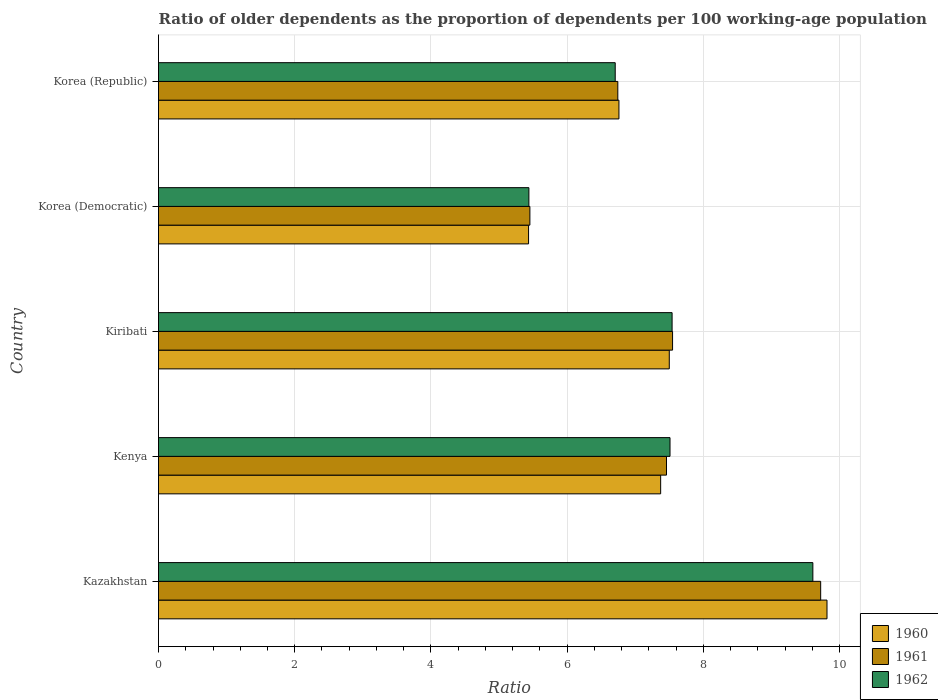How many different coloured bars are there?
Provide a succinct answer. 3. Are the number of bars on each tick of the Y-axis equal?
Offer a terse response. Yes. What is the label of the 3rd group of bars from the top?
Your response must be concise. Kiribati. What is the age dependency ratio(old) in 1962 in Kiribati?
Your response must be concise. 7.54. Across all countries, what is the maximum age dependency ratio(old) in 1960?
Your answer should be compact. 9.81. Across all countries, what is the minimum age dependency ratio(old) in 1962?
Offer a very short reply. 5.44. In which country was the age dependency ratio(old) in 1962 maximum?
Offer a very short reply. Kazakhstan. In which country was the age dependency ratio(old) in 1962 minimum?
Make the answer very short. Korea (Democratic). What is the total age dependency ratio(old) in 1962 in the graph?
Provide a succinct answer. 36.8. What is the difference between the age dependency ratio(old) in 1962 in Kazakhstan and that in Kiribati?
Provide a short and direct response. 2.07. What is the difference between the age dependency ratio(old) in 1960 in Kiribati and the age dependency ratio(old) in 1961 in Kenya?
Ensure brevity in your answer.  0.04. What is the average age dependency ratio(old) in 1961 per country?
Provide a short and direct response. 7.38. What is the difference between the age dependency ratio(old) in 1960 and age dependency ratio(old) in 1962 in Korea (Republic)?
Make the answer very short. 0.05. In how many countries, is the age dependency ratio(old) in 1961 greater than 0.4 ?
Your answer should be compact. 5. What is the ratio of the age dependency ratio(old) in 1962 in Kazakhstan to that in Kiribati?
Make the answer very short. 1.27. What is the difference between the highest and the second highest age dependency ratio(old) in 1962?
Offer a very short reply. 2.07. What is the difference between the highest and the lowest age dependency ratio(old) in 1961?
Your response must be concise. 4.27. Is the sum of the age dependency ratio(old) in 1961 in Kenya and Korea (Democratic) greater than the maximum age dependency ratio(old) in 1962 across all countries?
Give a very brief answer. Yes. What does the 1st bar from the bottom in Kenya represents?
Make the answer very short. 1960. Is it the case that in every country, the sum of the age dependency ratio(old) in 1961 and age dependency ratio(old) in 1962 is greater than the age dependency ratio(old) in 1960?
Your response must be concise. Yes. How many bars are there?
Provide a short and direct response. 15. Are all the bars in the graph horizontal?
Offer a terse response. Yes. How many countries are there in the graph?
Provide a succinct answer. 5. What is the difference between two consecutive major ticks on the X-axis?
Ensure brevity in your answer.  2. Are the values on the major ticks of X-axis written in scientific E-notation?
Offer a very short reply. No. Does the graph contain any zero values?
Provide a succinct answer. No. Where does the legend appear in the graph?
Provide a succinct answer. Bottom right. What is the title of the graph?
Provide a succinct answer. Ratio of older dependents as the proportion of dependents per 100 working-age population. Does "2015" appear as one of the legend labels in the graph?
Provide a succinct answer. No. What is the label or title of the X-axis?
Your response must be concise. Ratio. What is the Ratio in 1960 in Kazakhstan?
Make the answer very short. 9.81. What is the Ratio in 1961 in Kazakhstan?
Ensure brevity in your answer.  9.72. What is the Ratio of 1962 in Kazakhstan?
Your answer should be compact. 9.61. What is the Ratio of 1960 in Kenya?
Your response must be concise. 7.37. What is the Ratio in 1961 in Kenya?
Offer a terse response. 7.46. What is the Ratio in 1962 in Kenya?
Provide a succinct answer. 7.51. What is the Ratio in 1960 in Kiribati?
Ensure brevity in your answer.  7.5. What is the Ratio in 1961 in Kiribati?
Your answer should be compact. 7.55. What is the Ratio of 1962 in Kiribati?
Your answer should be compact. 7.54. What is the Ratio in 1960 in Korea (Democratic)?
Offer a terse response. 5.43. What is the Ratio of 1961 in Korea (Democratic)?
Provide a succinct answer. 5.45. What is the Ratio of 1962 in Korea (Democratic)?
Provide a short and direct response. 5.44. What is the Ratio of 1960 in Korea (Republic)?
Keep it short and to the point. 6.76. What is the Ratio in 1961 in Korea (Republic)?
Make the answer very short. 6.74. What is the Ratio in 1962 in Korea (Republic)?
Your response must be concise. 6.7. Across all countries, what is the maximum Ratio of 1960?
Provide a short and direct response. 9.81. Across all countries, what is the maximum Ratio of 1961?
Your answer should be compact. 9.72. Across all countries, what is the maximum Ratio in 1962?
Offer a very short reply. 9.61. Across all countries, what is the minimum Ratio in 1960?
Your answer should be very brief. 5.43. Across all countries, what is the minimum Ratio of 1961?
Your response must be concise. 5.45. Across all countries, what is the minimum Ratio of 1962?
Your answer should be compact. 5.44. What is the total Ratio in 1960 in the graph?
Ensure brevity in your answer.  36.88. What is the total Ratio in 1961 in the graph?
Your answer should be very brief. 36.92. What is the total Ratio in 1962 in the graph?
Offer a terse response. 36.8. What is the difference between the Ratio of 1960 in Kazakhstan and that in Kenya?
Your answer should be compact. 2.44. What is the difference between the Ratio of 1961 in Kazakhstan and that in Kenya?
Ensure brevity in your answer.  2.26. What is the difference between the Ratio of 1962 in Kazakhstan and that in Kenya?
Make the answer very short. 2.1. What is the difference between the Ratio of 1960 in Kazakhstan and that in Kiribati?
Ensure brevity in your answer.  2.32. What is the difference between the Ratio in 1961 in Kazakhstan and that in Kiribati?
Give a very brief answer. 2.17. What is the difference between the Ratio in 1962 in Kazakhstan and that in Kiribati?
Offer a very short reply. 2.07. What is the difference between the Ratio in 1960 in Kazakhstan and that in Korea (Democratic)?
Your response must be concise. 4.38. What is the difference between the Ratio of 1961 in Kazakhstan and that in Korea (Democratic)?
Your response must be concise. 4.27. What is the difference between the Ratio in 1962 in Kazakhstan and that in Korea (Democratic)?
Provide a succinct answer. 4.17. What is the difference between the Ratio of 1960 in Kazakhstan and that in Korea (Republic)?
Offer a very short reply. 3.05. What is the difference between the Ratio of 1961 in Kazakhstan and that in Korea (Republic)?
Your answer should be compact. 2.98. What is the difference between the Ratio in 1962 in Kazakhstan and that in Korea (Republic)?
Offer a very short reply. 2.9. What is the difference between the Ratio of 1960 in Kenya and that in Kiribati?
Give a very brief answer. -0.13. What is the difference between the Ratio in 1961 in Kenya and that in Kiribati?
Give a very brief answer. -0.09. What is the difference between the Ratio in 1962 in Kenya and that in Kiribati?
Your response must be concise. -0.03. What is the difference between the Ratio of 1960 in Kenya and that in Korea (Democratic)?
Keep it short and to the point. 1.94. What is the difference between the Ratio of 1961 in Kenya and that in Korea (Democratic)?
Ensure brevity in your answer.  2.01. What is the difference between the Ratio of 1962 in Kenya and that in Korea (Democratic)?
Your answer should be very brief. 2.07. What is the difference between the Ratio of 1960 in Kenya and that in Korea (Republic)?
Your response must be concise. 0.61. What is the difference between the Ratio in 1961 in Kenya and that in Korea (Republic)?
Give a very brief answer. 0.71. What is the difference between the Ratio of 1962 in Kenya and that in Korea (Republic)?
Make the answer very short. 0.8. What is the difference between the Ratio in 1960 in Kiribati and that in Korea (Democratic)?
Ensure brevity in your answer.  2.07. What is the difference between the Ratio of 1961 in Kiribati and that in Korea (Democratic)?
Offer a terse response. 2.09. What is the difference between the Ratio of 1962 in Kiribati and that in Korea (Democratic)?
Offer a very short reply. 2.1. What is the difference between the Ratio in 1960 in Kiribati and that in Korea (Republic)?
Your response must be concise. 0.74. What is the difference between the Ratio of 1961 in Kiribati and that in Korea (Republic)?
Provide a short and direct response. 0.8. What is the difference between the Ratio of 1962 in Kiribati and that in Korea (Republic)?
Your answer should be compact. 0.84. What is the difference between the Ratio of 1960 in Korea (Democratic) and that in Korea (Republic)?
Make the answer very short. -1.33. What is the difference between the Ratio of 1961 in Korea (Democratic) and that in Korea (Republic)?
Your answer should be very brief. -1.29. What is the difference between the Ratio in 1962 in Korea (Democratic) and that in Korea (Republic)?
Your answer should be compact. -1.27. What is the difference between the Ratio of 1960 in Kazakhstan and the Ratio of 1961 in Kenya?
Give a very brief answer. 2.36. What is the difference between the Ratio in 1960 in Kazakhstan and the Ratio in 1962 in Kenya?
Provide a short and direct response. 2.3. What is the difference between the Ratio of 1961 in Kazakhstan and the Ratio of 1962 in Kenya?
Your answer should be very brief. 2.21. What is the difference between the Ratio of 1960 in Kazakhstan and the Ratio of 1961 in Kiribati?
Provide a short and direct response. 2.27. What is the difference between the Ratio of 1960 in Kazakhstan and the Ratio of 1962 in Kiribati?
Your answer should be compact. 2.27. What is the difference between the Ratio in 1961 in Kazakhstan and the Ratio in 1962 in Kiribati?
Offer a very short reply. 2.18. What is the difference between the Ratio in 1960 in Kazakhstan and the Ratio in 1961 in Korea (Democratic)?
Offer a terse response. 4.36. What is the difference between the Ratio in 1960 in Kazakhstan and the Ratio in 1962 in Korea (Democratic)?
Your response must be concise. 4.38. What is the difference between the Ratio in 1961 in Kazakhstan and the Ratio in 1962 in Korea (Democratic)?
Your answer should be compact. 4.28. What is the difference between the Ratio of 1960 in Kazakhstan and the Ratio of 1961 in Korea (Republic)?
Give a very brief answer. 3.07. What is the difference between the Ratio of 1960 in Kazakhstan and the Ratio of 1962 in Korea (Republic)?
Provide a succinct answer. 3.11. What is the difference between the Ratio of 1961 in Kazakhstan and the Ratio of 1962 in Korea (Republic)?
Keep it short and to the point. 3.02. What is the difference between the Ratio in 1960 in Kenya and the Ratio in 1961 in Kiribati?
Offer a terse response. -0.17. What is the difference between the Ratio in 1960 in Kenya and the Ratio in 1962 in Kiribati?
Your answer should be compact. -0.17. What is the difference between the Ratio in 1961 in Kenya and the Ratio in 1962 in Kiribati?
Provide a short and direct response. -0.08. What is the difference between the Ratio of 1960 in Kenya and the Ratio of 1961 in Korea (Democratic)?
Your response must be concise. 1.92. What is the difference between the Ratio in 1960 in Kenya and the Ratio in 1962 in Korea (Democratic)?
Make the answer very short. 1.93. What is the difference between the Ratio of 1961 in Kenya and the Ratio of 1962 in Korea (Democratic)?
Provide a succinct answer. 2.02. What is the difference between the Ratio of 1960 in Kenya and the Ratio of 1961 in Korea (Republic)?
Provide a short and direct response. 0.63. What is the difference between the Ratio in 1960 in Kenya and the Ratio in 1962 in Korea (Republic)?
Provide a succinct answer. 0.67. What is the difference between the Ratio in 1961 in Kenya and the Ratio in 1962 in Korea (Republic)?
Keep it short and to the point. 0.75. What is the difference between the Ratio in 1960 in Kiribati and the Ratio in 1961 in Korea (Democratic)?
Provide a succinct answer. 2.05. What is the difference between the Ratio in 1960 in Kiribati and the Ratio in 1962 in Korea (Democratic)?
Ensure brevity in your answer.  2.06. What is the difference between the Ratio in 1961 in Kiribati and the Ratio in 1962 in Korea (Democratic)?
Provide a short and direct response. 2.11. What is the difference between the Ratio of 1960 in Kiribati and the Ratio of 1961 in Korea (Republic)?
Your response must be concise. 0.76. What is the difference between the Ratio in 1960 in Kiribati and the Ratio in 1962 in Korea (Republic)?
Provide a short and direct response. 0.79. What is the difference between the Ratio of 1961 in Kiribati and the Ratio of 1962 in Korea (Republic)?
Ensure brevity in your answer.  0.84. What is the difference between the Ratio in 1960 in Korea (Democratic) and the Ratio in 1961 in Korea (Republic)?
Ensure brevity in your answer.  -1.31. What is the difference between the Ratio of 1960 in Korea (Democratic) and the Ratio of 1962 in Korea (Republic)?
Ensure brevity in your answer.  -1.27. What is the difference between the Ratio in 1961 in Korea (Democratic) and the Ratio in 1962 in Korea (Republic)?
Provide a short and direct response. -1.25. What is the average Ratio in 1960 per country?
Give a very brief answer. 7.38. What is the average Ratio of 1961 per country?
Give a very brief answer. 7.38. What is the average Ratio in 1962 per country?
Offer a very short reply. 7.36. What is the difference between the Ratio in 1960 and Ratio in 1961 in Kazakhstan?
Offer a terse response. 0.09. What is the difference between the Ratio of 1960 and Ratio of 1962 in Kazakhstan?
Your response must be concise. 0.21. What is the difference between the Ratio of 1961 and Ratio of 1962 in Kazakhstan?
Offer a terse response. 0.11. What is the difference between the Ratio of 1960 and Ratio of 1961 in Kenya?
Make the answer very short. -0.09. What is the difference between the Ratio in 1960 and Ratio in 1962 in Kenya?
Provide a succinct answer. -0.14. What is the difference between the Ratio in 1961 and Ratio in 1962 in Kenya?
Your answer should be compact. -0.05. What is the difference between the Ratio of 1960 and Ratio of 1961 in Kiribati?
Your answer should be compact. -0.05. What is the difference between the Ratio of 1960 and Ratio of 1962 in Kiribati?
Offer a very short reply. -0.04. What is the difference between the Ratio in 1961 and Ratio in 1962 in Kiribati?
Keep it short and to the point. 0.01. What is the difference between the Ratio in 1960 and Ratio in 1961 in Korea (Democratic)?
Your answer should be very brief. -0.02. What is the difference between the Ratio of 1960 and Ratio of 1962 in Korea (Democratic)?
Ensure brevity in your answer.  -0. What is the difference between the Ratio in 1961 and Ratio in 1962 in Korea (Democratic)?
Make the answer very short. 0.01. What is the difference between the Ratio in 1960 and Ratio in 1961 in Korea (Republic)?
Offer a terse response. 0.02. What is the difference between the Ratio in 1960 and Ratio in 1962 in Korea (Republic)?
Your answer should be compact. 0.05. What is the difference between the Ratio in 1961 and Ratio in 1962 in Korea (Republic)?
Make the answer very short. 0.04. What is the ratio of the Ratio in 1960 in Kazakhstan to that in Kenya?
Your answer should be very brief. 1.33. What is the ratio of the Ratio of 1961 in Kazakhstan to that in Kenya?
Make the answer very short. 1.3. What is the ratio of the Ratio of 1962 in Kazakhstan to that in Kenya?
Your answer should be very brief. 1.28. What is the ratio of the Ratio in 1960 in Kazakhstan to that in Kiribati?
Provide a succinct answer. 1.31. What is the ratio of the Ratio of 1961 in Kazakhstan to that in Kiribati?
Your response must be concise. 1.29. What is the ratio of the Ratio in 1962 in Kazakhstan to that in Kiribati?
Provide a succinct answer. 1.27. What is the ratio of the Ratio of 1960 in Kazakhstan to that in Korea (Democratic)?
Your answer should be very brief. 1.81. What is the ratio of the Ratio in 1961 in Kazakhstan to that in Korea (Democratic)?
Offer a very short reply. 1.78. What is the ratio of the Ratio of 1962 in Kazakhstan to that in Korea (Democratic)?
Provide a short and direct response. 1.77. What is the ratio of the Ratio in 1960 in Kazakhstan to that in Korea (Republic)?
Offer a very short reply. 1.45. What is the ratio of the Ratio of 1961 in Kazakhstan to that in Korea (Republic)?
Your answer should be very brief. 1.44. What is the ratio of the Ratio in 1962 in Kazakhstan to that in Korea (Republic)?
Keep it short and to the point. 1.43. What is the ratio of the Ratio of 1960 in Kenya to that in Kiribati?
Offer a very short reply. 0.98. What is the ratio of the Ratio in 1961 in Kenya to that in Kiribati?
Keep it short and to the point. 0.99. What is the ratio of the Ratio in 1960 in Kenya to that in Korea (Democratic)?
Your answer should be very brief. 1.36. What is the ratio of the Ratio of 1961 in Kenya to that in Korea (Democratic)?
Ensure brevity in your answer.  1.37. What is the ratio of the Ratio in 1962 in Kenya to that in Korea (Democratic)?
Offer a terse response. 1.38. What is the ratio of the Ratio of 1960 in Kenya to that in Korea (Republic)?
Offer a very short reply. 1.09. What is the ratio of the Ratio in 1961 in Kenya to that in Korea (Republic)?
Provide a short and direct response. 1.11. What is the ratio of the Ratio in 1962 in Kenya to that in Korea (Republic)?
Provide a succinct answer. 1.12. What is the ratio of the Ratio in 1960 in Kiribati to that in Korea (Democratic)?
Keep it short and to the point. 1.38. What is the ratio of the Ratio of 1961 in Kiribati to that in Korea (Democratic)?
Your answer should be very brief. 1.38. What is the ratio of the Ratio in 1962 in Kiribati to that in Korea (Democratic)?
Offer a terse response. 1.39. What is the ratio of the Ratio of 1960 in Kiribati to that in Korea (Republic)?
Offer a very short reply. 1.11. What is the ratio of the Ratio in 1961 in Kiribati to that in Korea (Republic)?
Provide a succinct answer. 1.12. What is the ratio of the Ratio of 1962 in Kiribati to that in Korea (Republic)?
Your answer should be very brief. 1.12. What is the ratio of the Ratio of 1960 in Korea (Democratic) to that in Korea (Republic)?
Keep it short and to the point. 0.8. What is the ratio of the Ratio in 1961 in Korea (Democratic) to that in Korea (Republic)?
Your response must be concise. 0.81. What is the ratio of the Ratio in 1962 in Korea (Democratic) to that in Korea (Republic)?
Make the answer very short. 0.81. What is the difference between the highest and the second highest Ratio in 1960?
Make the answer very short. 2.32. What is the difference between the highest and the second highest Ratio in 1961?
Offer a terse response. 2.17. What is the difference between the highest and the second highest Ratio of 1962?
Offer a terse response. 2.07. What is the difference between the highest and the lowest Ratio of 1960?
Ensure brevity in your answer.  4.38. What is the difference between the highest and the lowest Ratio of 1961?
Keep it short and to the point. 4.27. What is the difference between the highest and the lowest Ratio of 1962?
Offer a terse response. 4.17. 